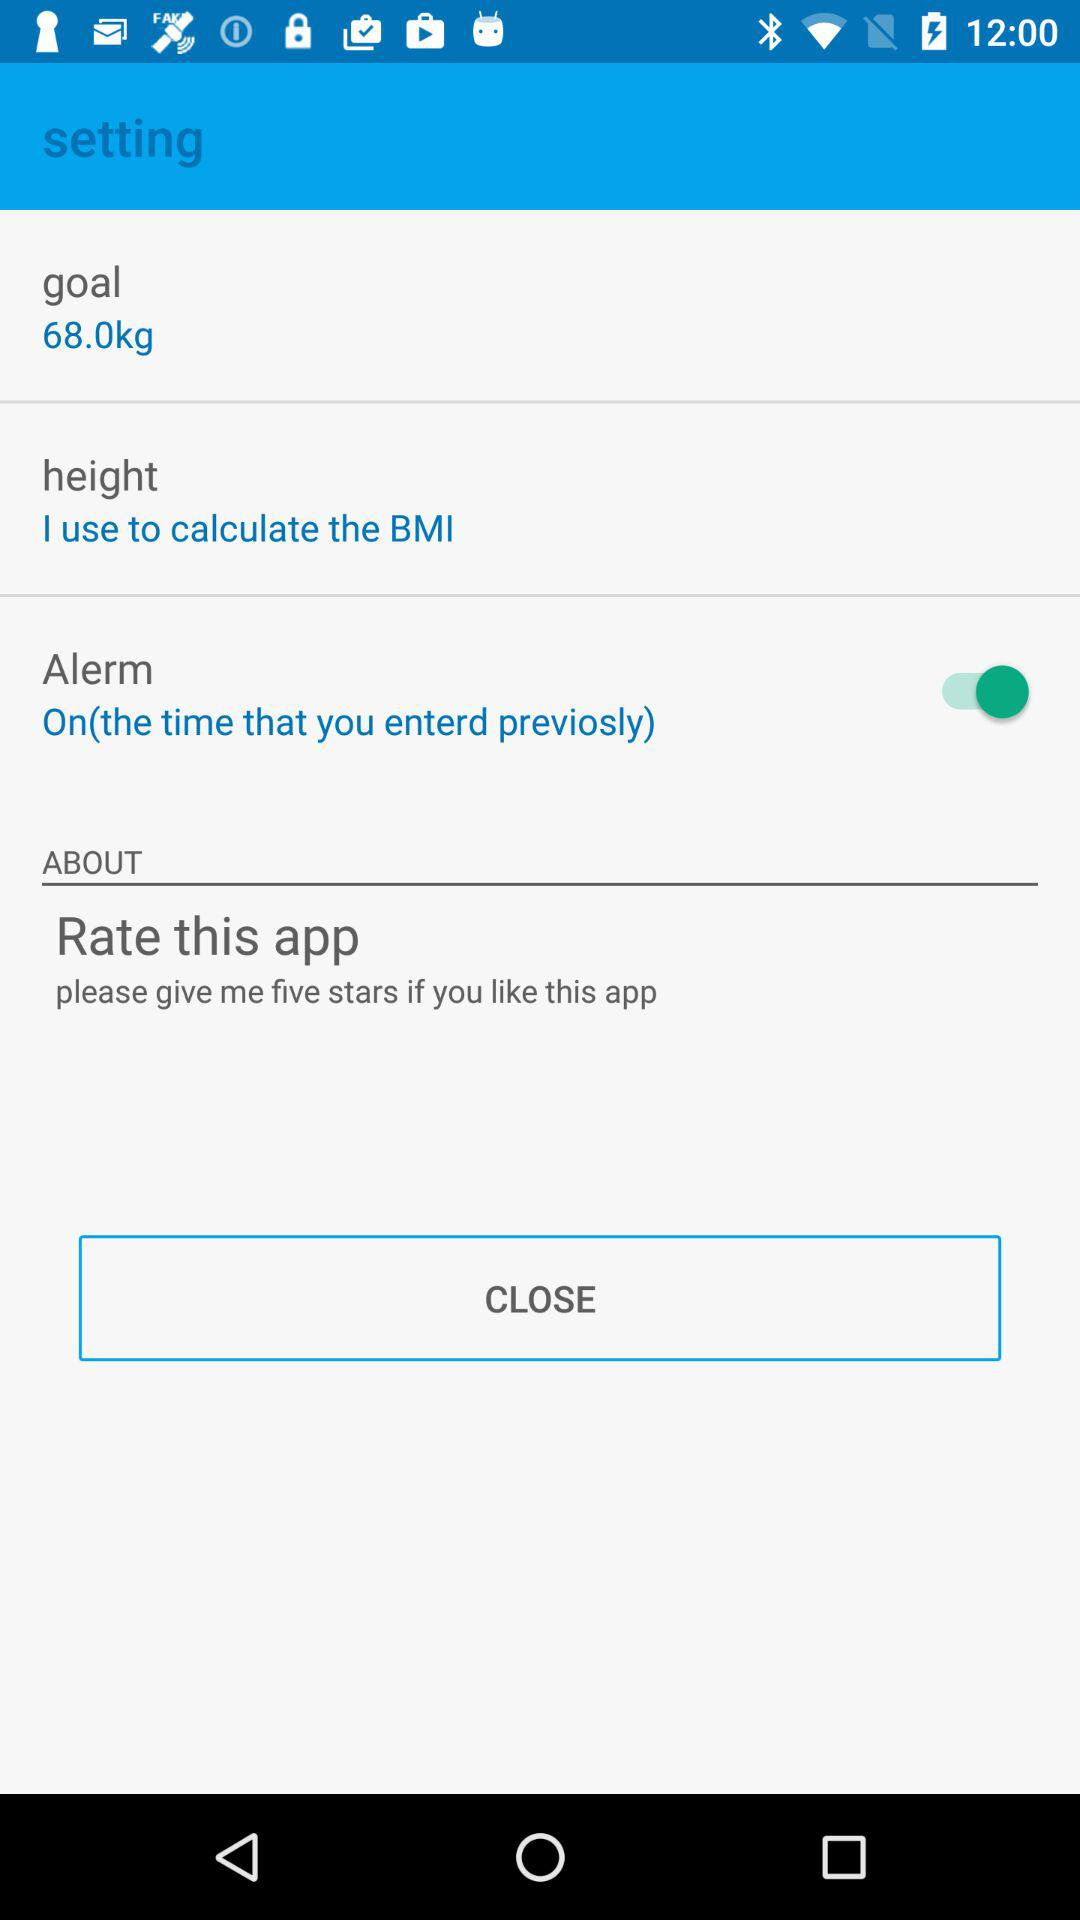What is the given goal weight? The given goal weight is 68 kg. 